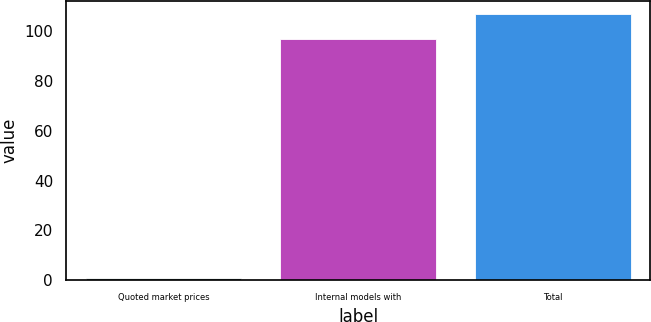Convert chart. <chart><loc_0><loc_0><loc_500><loc_500><bar_chart><fcel>Quoted market prices<fcel>Internal models with<fcel>Total<nl><fcel>1<fcel>97<fcel>106.9<nl></chart> 